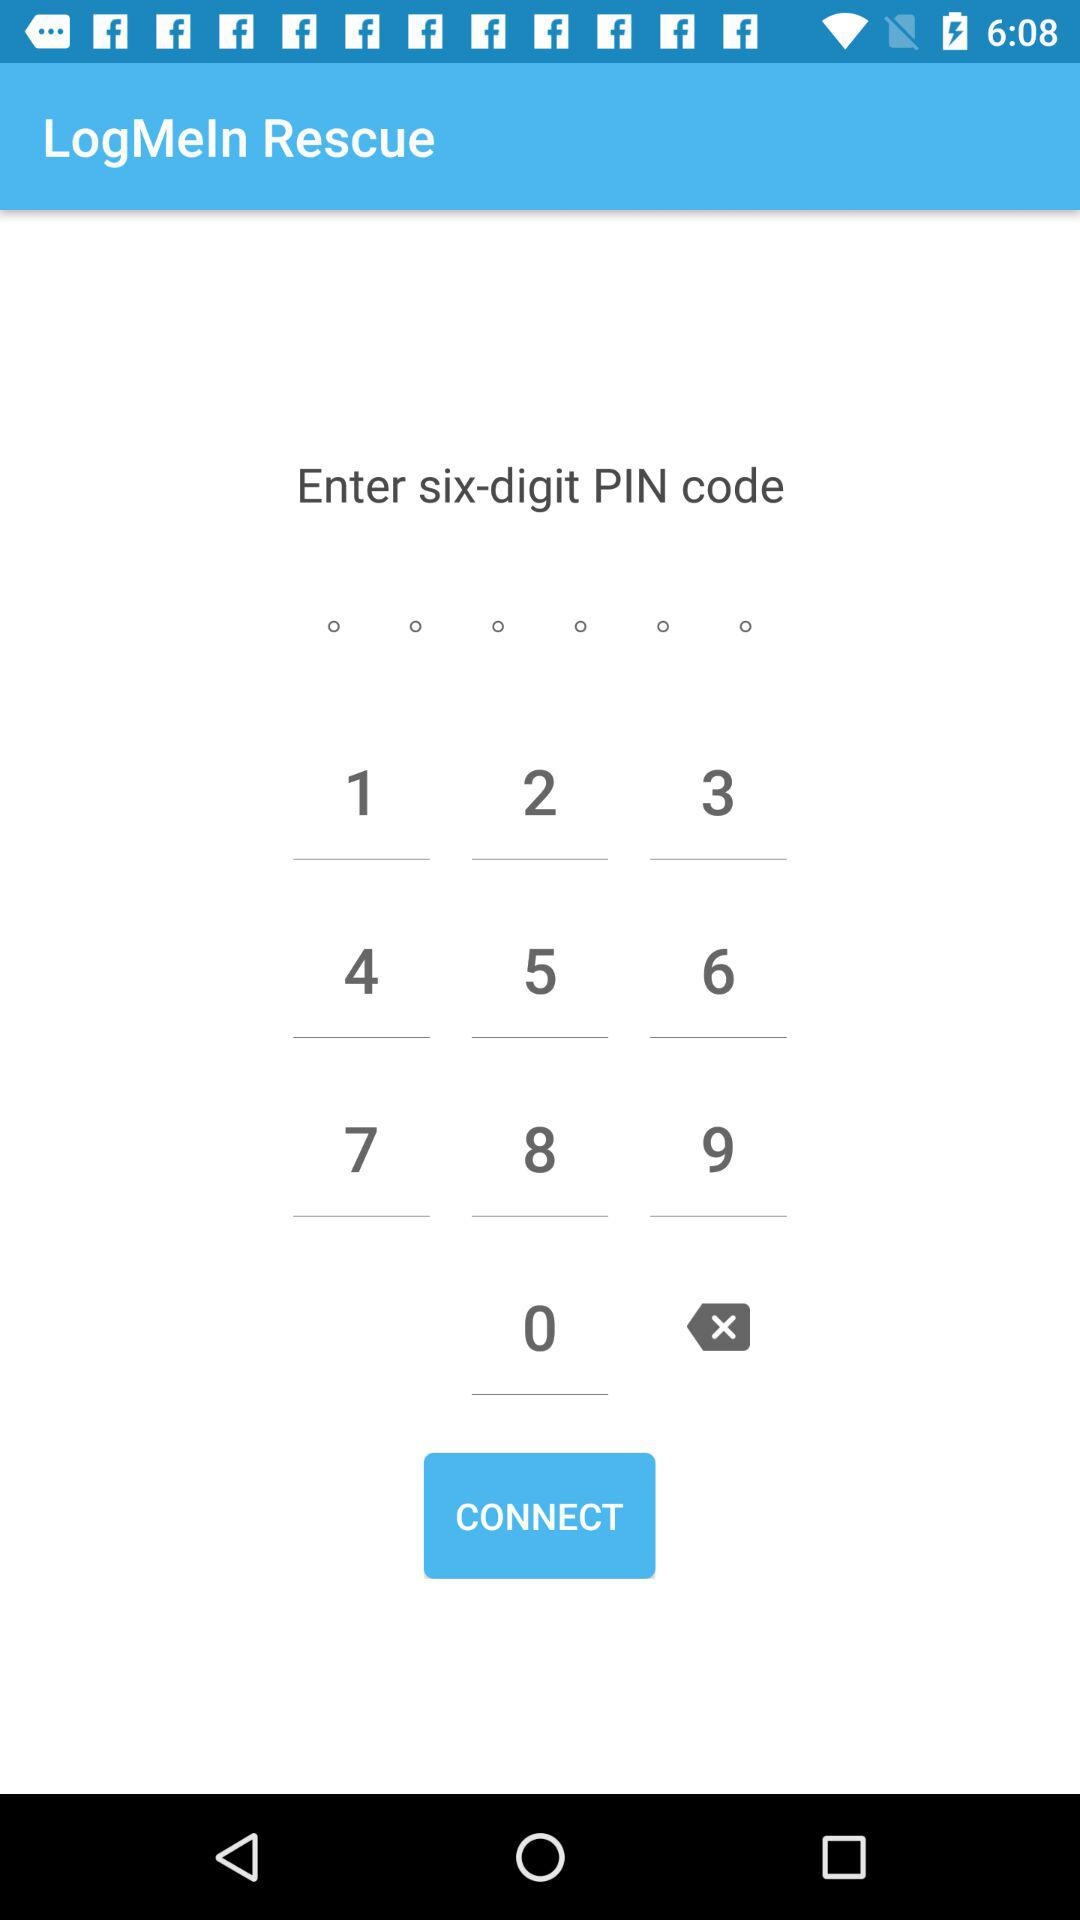How many pin code digits need to be entered? There are six pin code digits that need to be entered. 